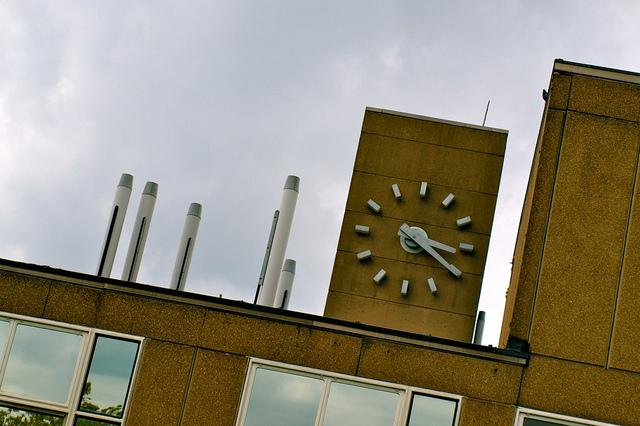Is this clock inside or outside?
Answer briefly. Outside. How many birds are on the wall?
Write a very short answer. 0. What does the time read?
Give a very brief answer. 3:20. What time was it 59 minutes ago?
Short answer required. 2:20. Does this appear to be a place of business?
Give a very brief answer. Yes. What color is the brick?
Concise answer only. Brown. How many clocks can be seen?
Quick response, please. 1. What time does the clock say?
Answer briefly. 3:20. How many clocks are in the image?
Keep it brief. 1. Is there anything written?
Short answer required. No. Why does the shape of the clock look so dangerous?
Quick response, please. It does not. Are there Roman numerals on the clock?
Answer briefly. No. What time is it on the clock?
Write a very short answer. 3:20. What time is it?
Quick response, please. 3:20. Are there clouds in the sky?
Quick response, please. Yes. 